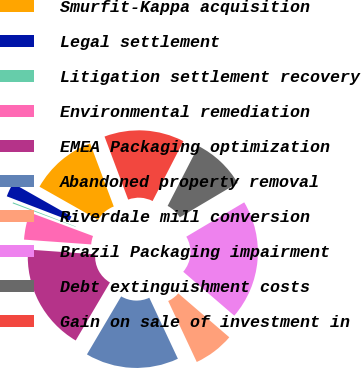<chart> <loc_0><loc_0><loc_500><loc_500><pie_chart><fcel>Smurfit-Kappa acquisition<fcel>Legal settlement<fcel>Litigation settlement recovery<fcel>Environmental remediation<fcel>EMEA Packaging optimization<fcel>Abandoned property removal<fcel>Riverdale mill conversion<fcel>Brazil Packaging impairment<fcel>Debt extinguishment costs<fcel>Gain on sale of investment in<nl><fcel>11.09%<fcel>2.35%<fcel>0.17%<fcel>4.54%<fcel>17.65%<fcel>15.46%<fcel>6.72%<fcel>19.83%<fcel>8.91%<fcel>13.28%<nl></chart> 